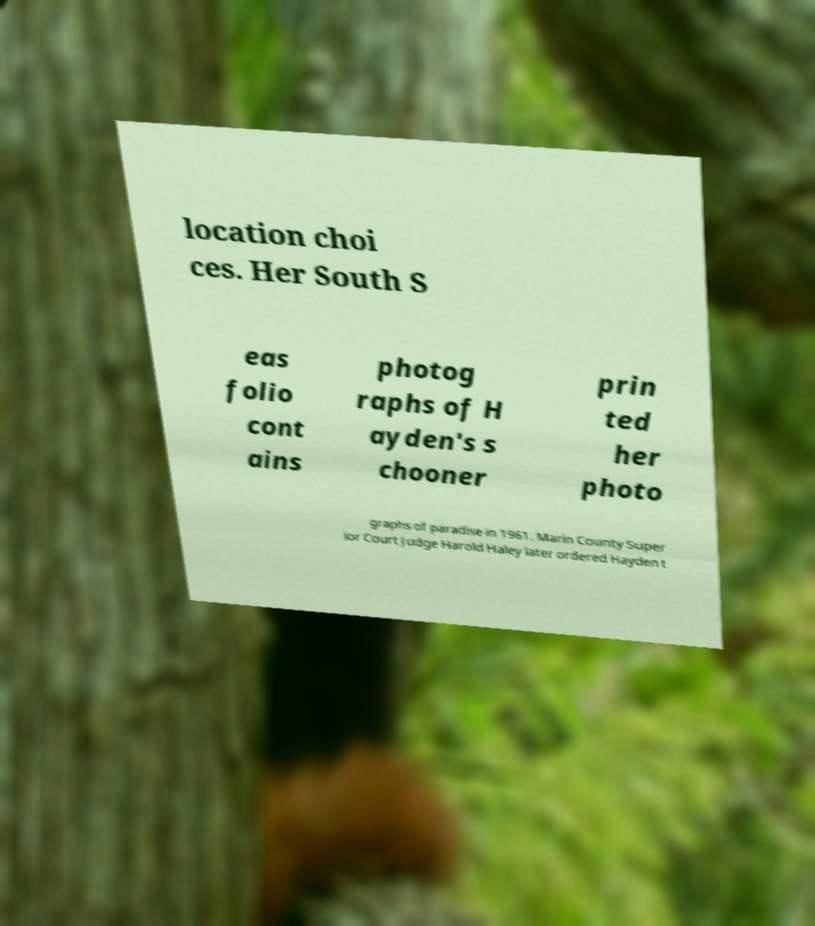Please read and relay the text visible in this image. What does it say? location choi ces. Her South S eas folio cont ains photog raphs of H ayden's s chooner prin ted her photo graphs of paradise in 1961. Marin County Super ior Court Judge Harold Haley later ordered Hayden t 